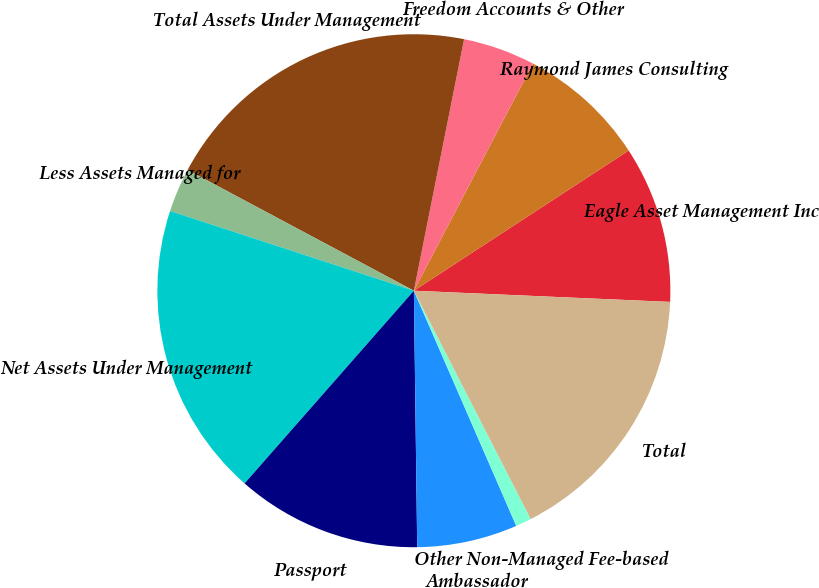Convert chart to OTSL. <chart><loc_0><loc_0><loc_500><loc_500><pie_chart><fcel>Eagle Asset Management Inc<fcel>Raymond James Consulting<fcel>Freedom Accounts & Other<fcel>Total Assets Under Management<fcel>Less Assets Managed for<fcel>Net Assets Under Management<fcel>Passport<fcel>Ambassador<fcel>Other Non-Managed Fee-based<fcel>Total<nl><fcel>9.9%<fcel>8.11%<fcel>4.55%<fcel>20.34%<fcel>2.77%<fcel>18.56%<fcel>11.68%<fcel>6.33%<fcel>0.99%<fcel>16.78%<nl></chart> 